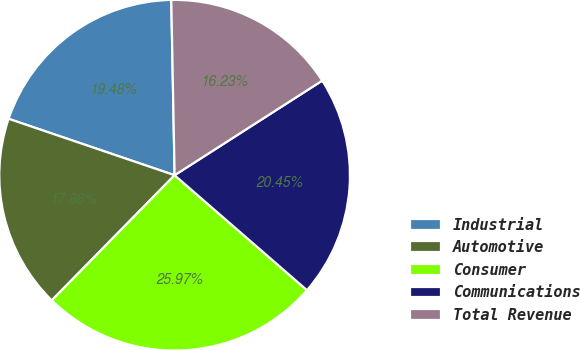<chart> <loc_0><loc_0><loc_500><loc_500><pie_chart><fcel>Industrial<fcel>Automotive<fcel>Consumer<fcel>Communications<fcel>Total Revenue<nl><fcel>19.48%<fcel>17.86%<fcel>25.97%<fcel>20.45%<fcel>16.23%<nl></chart> 